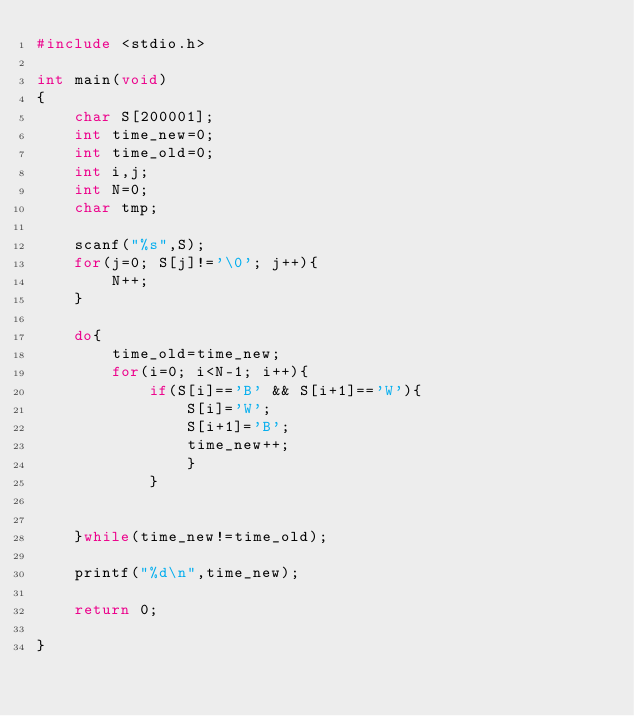<code> <loc_0><loc_0><loc_500><loc_500><_C_>#include <stdio.h>

int main(void)
{
    char S[200001];
    int time_new=0;
    int time_old=0;
    int i,j;
    int N=0;
    char tmp;
    
    scanf("%s",S);
    for(j=0; S[j]!='\0'; j++){
        N++;
    }
    
    do{
        time_old=time_new;
        for(i=0; i<N-1; i++){
            if(S[i]=='B' && S[i+1]=='W'){
                S[i]='W';
                S[i+1]='B';
                time_new++;
                }
            }
        
       
    }while(time_new!=time_old);

    printf("%d\n",time_new);
    
    return 0;

}
</code> 